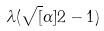<formula> <loc_0><loc_0><loc_500><loc_500>\lambda ( \sqrt { [ } \alpha ] { 2 } - 1 )</formula> 